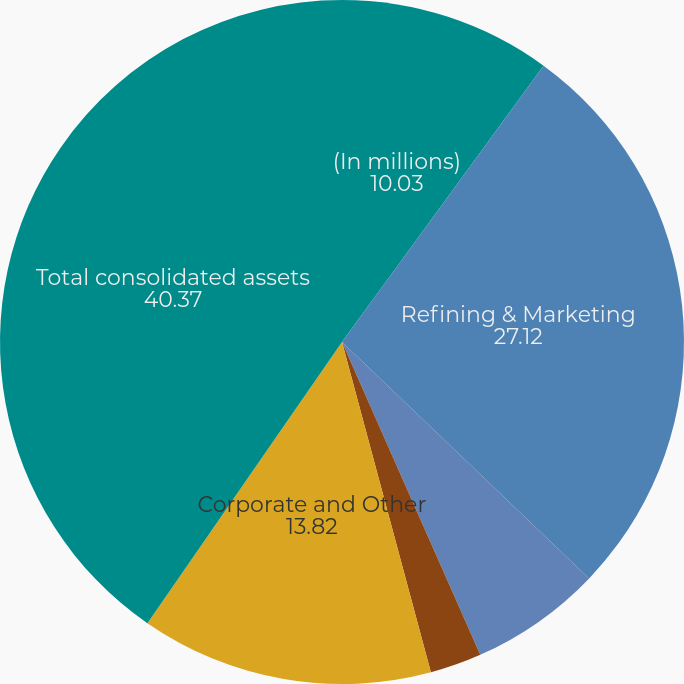<chart> <loc_0><loc_0><loc_500><loc_500><pie_chart><fcel>(In millions)<fcel>Refining & Marketing<fcel>Speedway<fcel>Pipeline Transportation<fcel>Corporate and Other<fcel>Total consolidated assets<nl><fcel>10.03%<fcel>27.12%<fcel>6.23%<fcel>2.44%<fcel>13.82%<fcel>40.37%<nl></chart> 